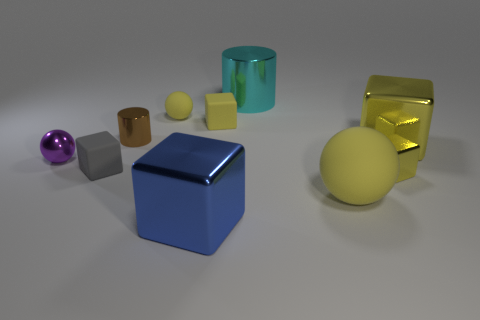Subtract all red balls. How many yellow cubes are left? 3 Subtract all gray blocks. How many blocks are left? 4 Subtract all blue cubes. How many cubes are left? 4 Subtract all green cubes. Subtract all brown cylinders. How many cubes are left? 5 Subtract all spheres. How many objects are left? 7 Add 9 yellow matte cubes. How many yellow matte cubes exist? 10 Subtract 1 cyan cylinders. How many objects are left? 9 Subtract all cyan metal objects. Subtract all large blue cubes. How many objects are left? 8 Add 3 spheres. How many spheres are left? 6 